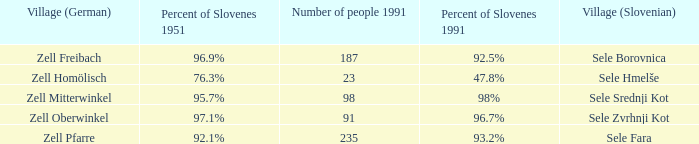Provide me with the name of all the village (German) that are part of the village (Slovenian) with sele srednji kot.  Zell Mitterwinkel. 